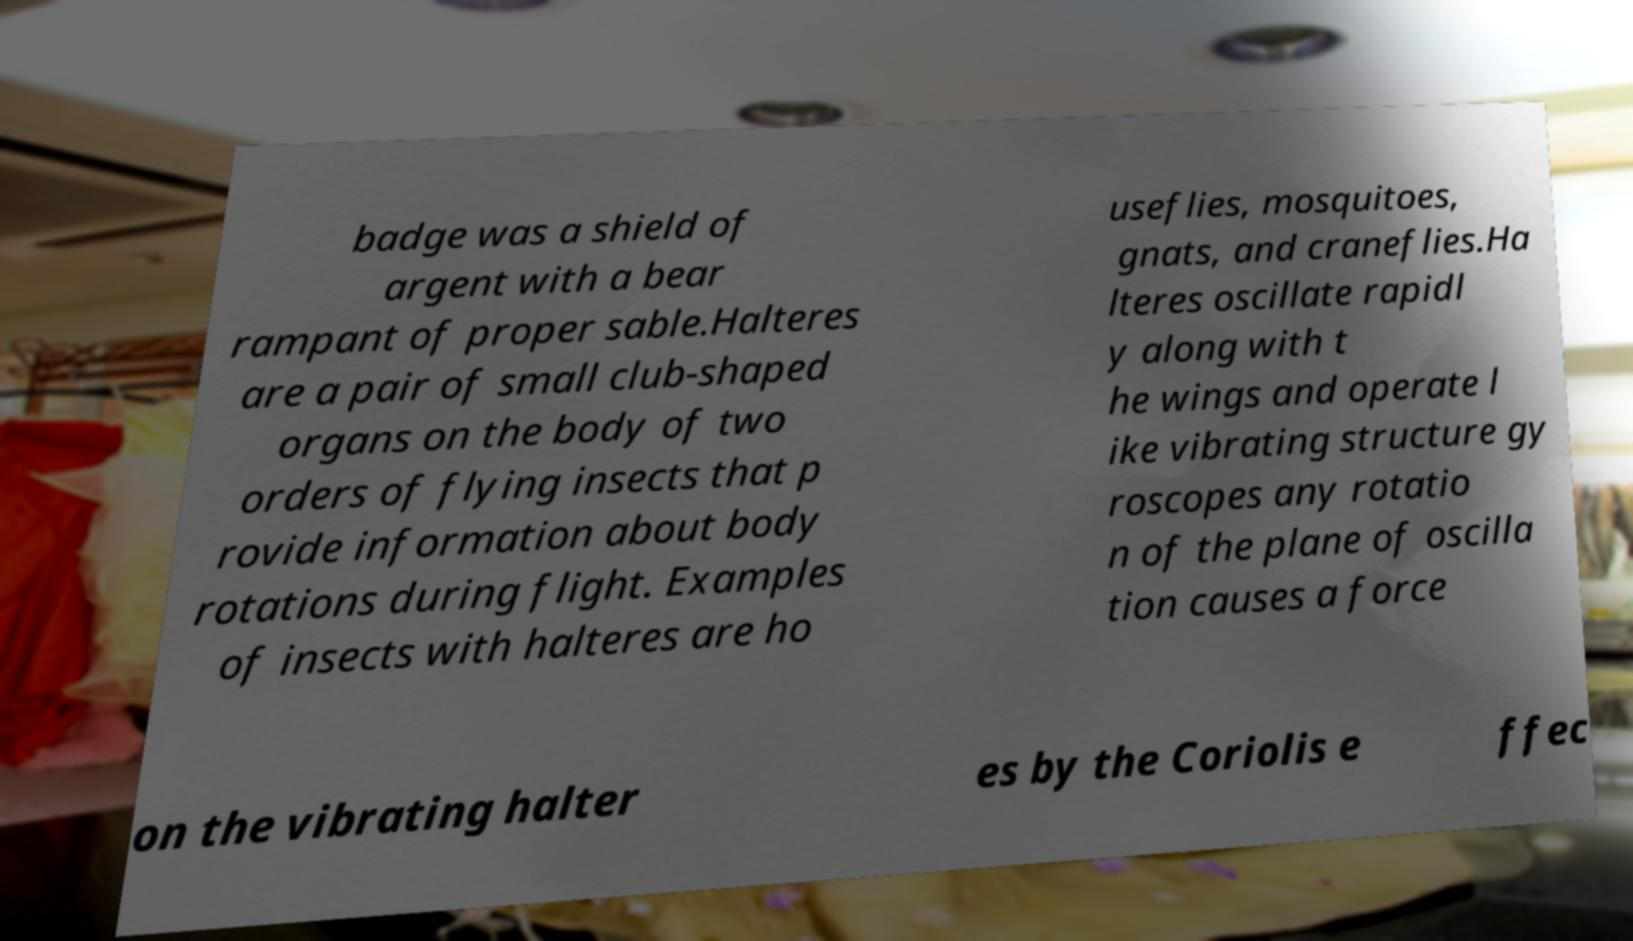There's text embedded in this image that I need extracted. Can you transcribe it verbatim? badge was a shield of argent with a bear rampant of proper sable.Halteres are a pair of small club-shaped organs on the body of two orders of flying insects that p rovide information about body rotations during flight. Examples of insects with halteres are ho useflies, mosquitoes, gnats, and craneflies.Ha lteres oscillate rapidl y along with t he wings and operate l ike vibrating structure gy roscopes any rotatio n of the plane of oscilla tion causes a force on the vibrating halter es by the Coriolis e ffec 